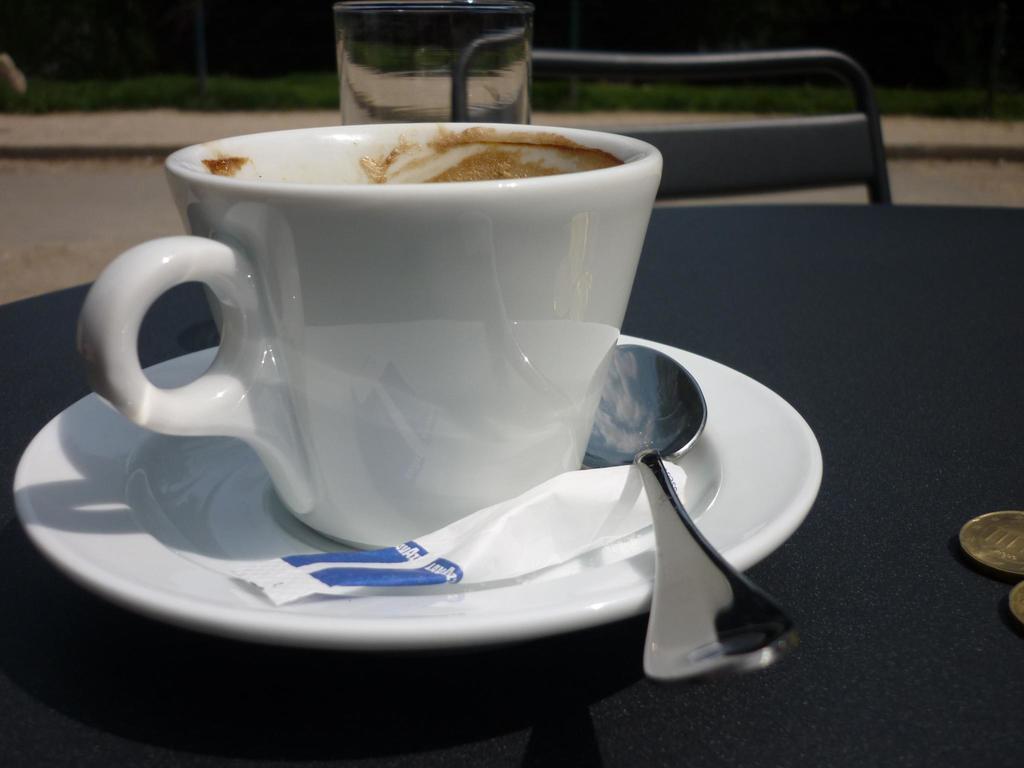Could you give a brief overview of what you see in this image? In this picture there is a cup, a saucer ,a bag and a spoon on the table. There is a chair. At the background there are some plants. 